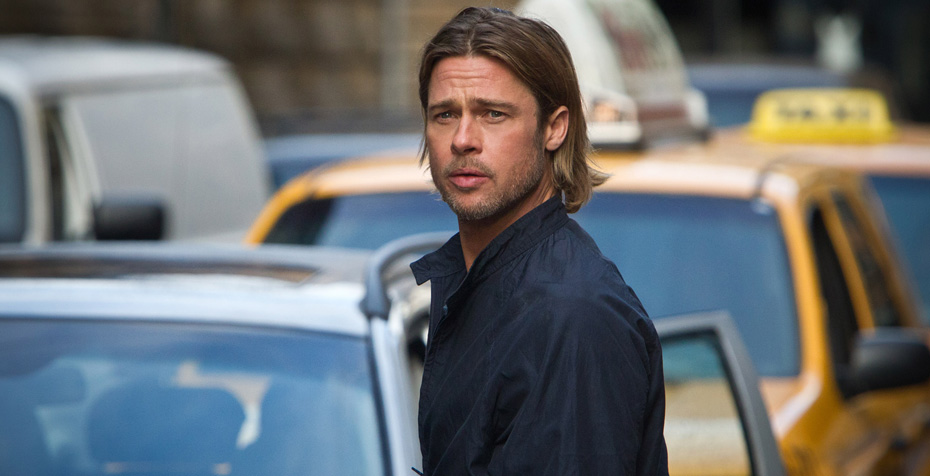Can you describe what the man might be thinking as he walks down the street? The man appears to be deep in thought as he walks down the busy city street. He might be pondering over a recent event or decision, perhaps contemplating his next steps or reflecting on his day. The intensity of his expression suggests that whatever occupies his mind is significant and commands his full attention. The urban environment around him fades away as he is consumed by his thoughts, leaving him momentarily isolated in his own world despite the bustling surroundings. 